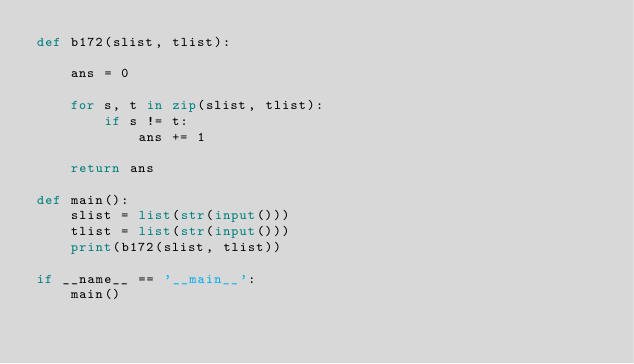<code> <loc_0><loc_0><loc_500><loc_500><_Python_>def b172(slist, tlist):

    ans = 0

    for s, t in zip(slist, tlist):
        if s != t:
            ans += 1

    return ans

def main():
    slist = list(str(input()))
    tlist = list(str(input()))
    print(b172(slist, tlist))

if __name__ == '__main__':
    main()</code> 